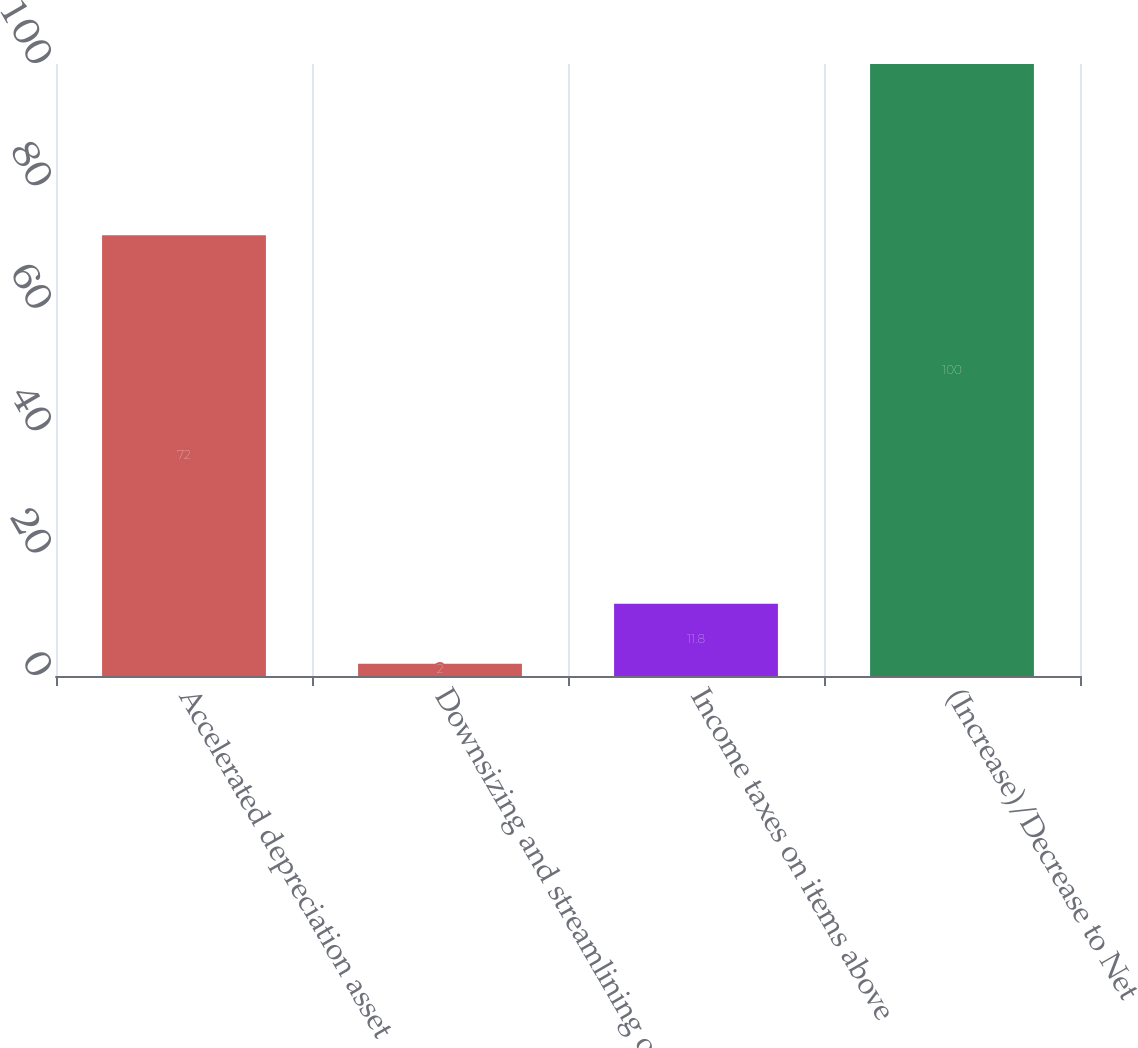Convert chart. <chart><loc_0><loc_0><loc_500><loc_500><bar_chart><fcel>Accelerated depreciation asset<fcel>Downsizing and streamlining of<fcel>Income taxes on items above<fcel>(Increase)/Decrease to Net<nl><fcel>72<fcel>2<fcel>11.8<fcel>100<nl></chart> 